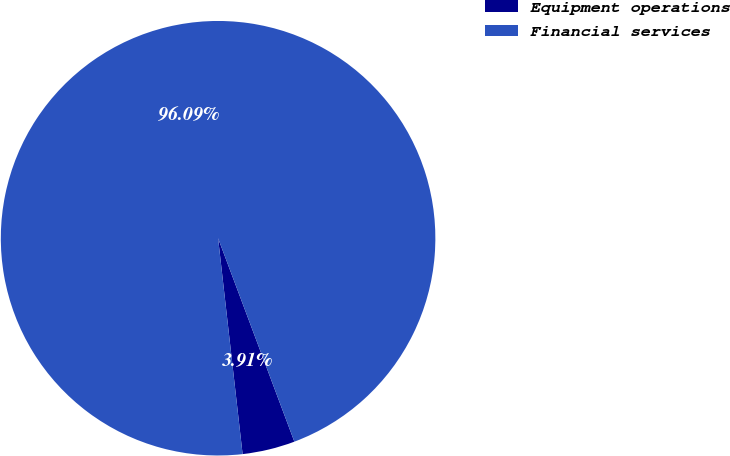<chart> <loc_0><loc_0><loc_500><loc_500><pie_chart><fcel>Equipment operations<fcel>Financial services<nl><fcel>3.91%<fcel>96.09%<nl></chart> 